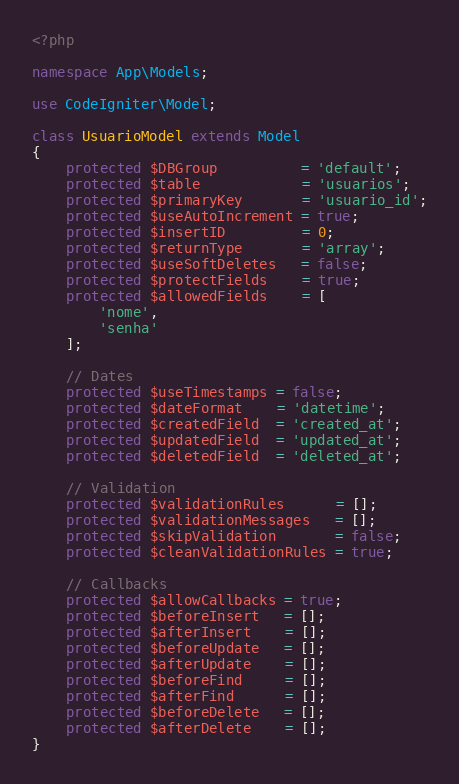Convert code to text. <code><loc_0><loc_0><loc_500><loc_500><_PHP_><?php

namespace App\Models;

use CodeIgniter\Model;

class UsuarioModel extends Model
{
    protected $DBGroup          = 'default';
    protected $table            = 'usuarios';
    protected $primaryKey       = 'usuario_id';
    protected $useAutoIncrement = true;
    protected $insertID         = 0;
    protected $returnType       = 'array';
    protected $useSoftDeletes   = false;
    protected $protectFields    = true;
    protected $allowedFields    = [
        'nome',
        'senha'
    ];

    // Dates
    protected $useTimestamps = false;
    protected $dateFormat    = 'datetime';
    protected $createdField  = 'created_at';
    protected $updatedField  = 'updated_at';
    protected $deletedField  = 'deleted_at';

    // Validation
    protected $validationRules      = [];
    protected $validationMessages   = [];
    protected $skipValidation       = false;
    protected $cleanValidationRules = true;

    // Callbacks
    protected $allowCallbacks = true;
    protected $beforeInsert   = [];
    protected $afterInsert    = [];
    protected $beforeUpdate   = [];
    protected $afterUpdate    = [];
    protected $beforeFind     = [];
    protected $afterFind      = [];
    protected $beforeDelete   = [];
    protected $afterDelete    = [];
}
</code> 